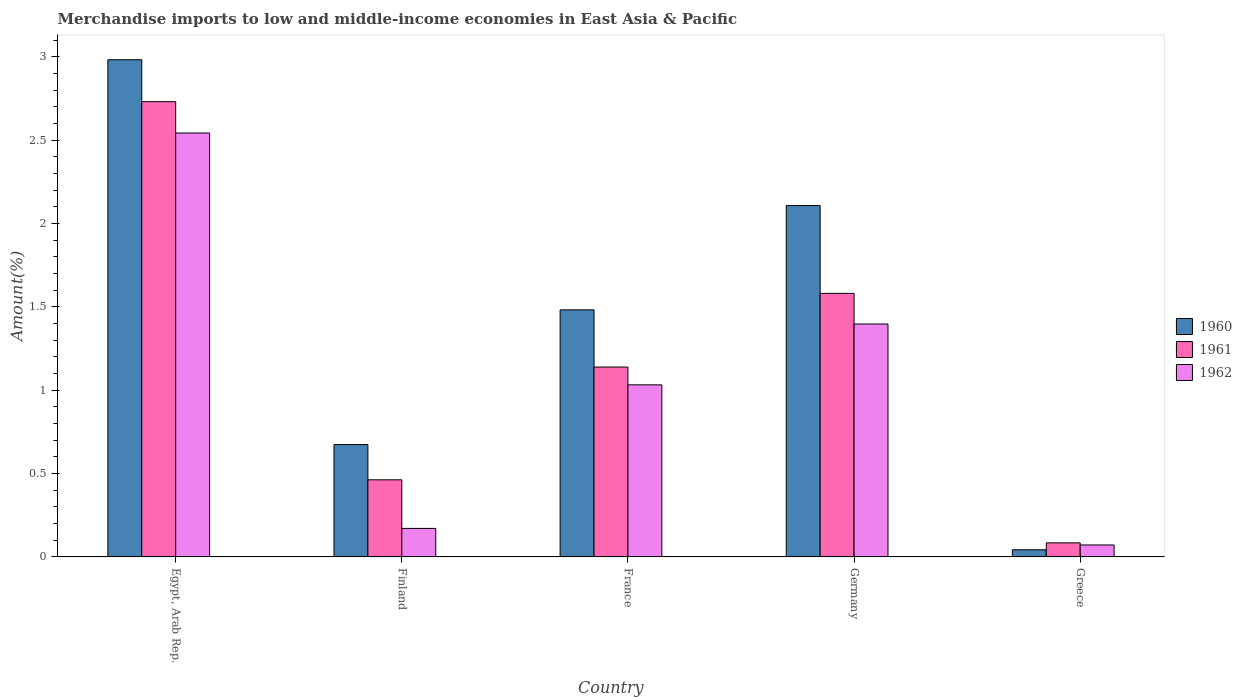How many groups of bars are there?
Provide a succinct answer. 5. Are the number of bars per tick equal to the number of legend labels?
Your answer should be very brief. Yes. Are the number of bars on each tick of the X-axis equal?
Offer a terse response. Yes. What is the label of the 1st group of bars from the left?
Make the answer very short. Egypt, Arab Rep. In how many cases, is the number of bars for a given country not equal to the number of legend labels?
Offer a terse response. 0. What is the percentage of amount earned from merchandise imports in 1960 in Germany?
Provide a succinct answer. 2.11. Across all countries, what is the maximum percentage of amount earned from merchandise imports in 1961?
Offer a terse response. 2.73. Across all countries, what is the minimum percentage of amount earned from merchandise imports in 1962?
Provide a succinct answer. 0.07. In which country was the percentage of amount earned from merchandise imports in 1962 maximum?
Keep it short and to the point. Egypt, Arab Rep. In which country was the percentage of amount earned from merchandise imports in 1962 minimum?
Ensure brevity in your answer.  Greece. What is the total percentage of amount earned from merchandise imports in 1961 in the graph?
Make the answer very short. 6. What is the difference between the percentage of amount earned from merchandise imports in 1960 in Finland and that in Germany?
Your response must be concise. -1.43. What is the difference between the percentage of amount earned from merchandise imports in 1960 in Greece and the percentage of amount earned from merchandise imports in 1961 in Egypt, Arab Rep.?
Offer a very short reply. -2.69. What is the average percentage of amount earned from merchandise imports in 1961 per country?
Your response must be concise. 1.2. What is the difference between the percentage of amount earned from merchandise imports of/in 1961 and percentage of amount earned from merchandise imports of/in 1962 in Greece?
Your response must be concise. 0.01. What is the ratio of the percentage of amount earned from merchandise imports in 1960 in Egypt, Arab Rep. to that in Germany?
Provide a short and direct response. 1.42. Is the difference between the percentage of amount earned from merchandise imports in 1961 in Egypt, Arab Rep. and Germany greater than the difference between the percentage of amount earned from merchandise imports in 1962 in Egypt, Arab Rep. and Germany?
Make the answer very short. Yes. What is the difference between the highest and the second highest percentage of amount earned from merchandise imports in 1962?
Make the answer very short. -1.15. What is the difference between the highest and the lowest percentage of amount earned from merchandise imports in 1960?
Offer a terse response. 2.94. In how many countries, is the percentage of amount earned from merchandise imports in 1962 greater than the average percentage of amount earned from merchandise imports in 1962 taken over all countries?
Provide a succinct answer. 2. Is it the case that in every country, the sum of the percentage of amount earned from merchandise imports in 1961 and percentage of amount earned from merchandise imports in 1960 is greater than the percentage of amount earned from merchandise imports in 1962?
Your answer should be compact. Yes. How many bars are there?
Ensure brevity in your answer.  15. Are all the bars in the graph horizontal?
Ensure brevity in your answer.  No. Does the graph contain any zero values?
Keep it short and to the point. No. Does the graph contain grids?
Ensure brevity in your answer.  No. Where does the legend appear in the graph?
Your answer should be very brief. Center right. How are the legend labels stacked?
Keep it short and to the point. Vertical. What is the title of the graph?
Your response must be concise. Merchandise imports to low and middle-income economies in East Asia & Pacific. What is the label or title of the X-axis?
Give a very brief answer. Country. What is the label or title of the Y-axis?
Your response must be concise. Amount(%). What is the Amount(%) of 1960 in Egypt, Arab Rep.?
Provide a succinct answer. 2.98. What is the Amount(%) in 1961 in Egypt, Arab Rep.?
Ensure brevity in your answer.  2.73. What is the Amount(%) in 1962 in Egypt, Arab Rep.?
Your response must be concise. 2.54. What is the Amount(%) in 1960 in Finland?
Give a very brief answer. 0.67. What is the Amount(%) in 1961 in Finland?
Make the answer very short. 0.46. What is the Amount(%) in 1962 in Finland?
Your answer should be very brief. 0.17. What is the Amount(%) of 1960 in France?
Your answer should be very brief. 1.48. What is the Amount(%) of 1961 in France?
Make the answer very short. 1.14. What is the Amount(%) of 1962 in France?
Provide a short and direct response. 1.03. What is the Amount(%) of 1960 in Germany?
Keep it short and to the point. 2.11. What is the Amount(%) of 1961 in Germany?
Your answer should be compact. 1.58. What is the Amount(%) of 1962 in Germany?
Your answer should be compact. 1.4. What is the Amount(%) in 1960 in Greece?
Keep it short and to the point. 0.04. What is the Amount(%) in 1961 in Greece?
Make the answer very short. 0.08. What is the Amount(%) in 1962 in Greece?
Offer a terse response. 0.07. Across all countries, what is the maximum Amount(%) of 1960?
Provide a short and direct response. 2.98. Across all countries, what is the maximum Amount(%) in 1961?
Your response must be concise. 2.73. Across all countries, what is the maximum Amount(%) in 1962?
Your answer should be very brief. 2.54. Across all countries, what is the minimum Amount(%) of 1960?
Your response must be concise. 0.04. Across all countries, what is the minimum Amount(%) in 1961?
Your answer should be compact. 0.08. Across all countries, what is the minimum Amount(%) in 1962?
Give a very brief answer. 0.07. What is the total Amount(%) in 1960 in the graph?
Offer a very short reply. 7.29. What is the total Amount(%) of 1961 in the graph?
Your answer should be very brief. 6. What is the total Amount(%) of 1962 in the graph?
Make the answer very short. 5.21. What is the difference between the Amount(%) of 1960 in Egypt, Arab Rep. and that in Finland?
Offer a very short reply. 2.31. What is the difference between the Amount(%) in 1961 in Egypt, Arab Rep. and that in Finland?
Your response must be concise. 2.27. What is the difference between the Amount(%) of 1962 in Egypt, Arab Rep. and that in Finland?
Your answer should be very brief. 2.37. What is the difference between the Amount(%) of 1961 in Egypt, Arab Rep. and that in France?
Your answer should be very brief. 1.59. What is the difference between the Amount(%) in 1962 in Egypt, Arab Rep. and that in France?
Offer a terse response. 1.51. What is the difference between the Amount(%) of 1960 in Egypt, Arab Rep. and that in Germany?
Provide a short and direct response. 0.87. What is the difference between the Amount(%) in 1961 in Egypt, Arab Rep. and that in Germany?
Your response must be concise. 1.15. What is the difference between the Amount(%) of 1962 in Egypt, Arab Rep. and that in Germany?
Ensure brevity in your answer.  1.15. What is the difference between the Amount(%) in 1960 in Egypt, Arab Rep. and that in Greece?
Ensure brevity in your answer.  2.94. What is the difference between the Amount(%) in 1961 in Egypt, Arab Rep. and that in Greece?
Make the answer very short. 2.65. What is the difference between the Amount(%) in 1962 in Egypt, Arab Rep. and that in Greece?
Ensure brevity in your answer.  2.47. What is the difference between the Amount(%) of 1960 in Finland and that in France?
Your response must be concise. -0.81. What is the difference between the Amount(%) in 1961 in Finland and that in France?
Keep it short and to the point. -0.68. What is the difference between the Amount(%) of 1962 in Finland and that in France?
Your answer should be very brief. -0.86. What is the difference between the Amount(%) of 1960 in Finland and that in Germany?
Your answer should be compact. -1.43. What is the difference between the Amount(%) of 1961 in Finland and that in Germany?
Your answer should be compact. -1.12. What is the difference between the Amount(%) of 1962 in Finland and that in Germany?
Your answer should be compact. -1.23. What is the difference between the Amount(%) of 1960 in Finland and that in Greece?
Offer a terse response. 0.63. What is the difference between the Amount(%) in 1961 in Finland and that in Greece?
Provide a succinct answer. 0.38. What is the difference between the Amount(%) in 1962 in Finland and that in Greece?
Provide a short and direct response. 0.1. What is the difference between the Amount(%) of 1960 in France and that in Germany?
Provide a succinct answer. -0.63. What is the difference between the Amount(%) in 1961 in France and that in Germany?
Offer a terse response. -0.44. What is the difference between the Amount(%) in 1962 in France and that in Germany?
Offer a very short reply. -0.36. What is the difference between the Amount(%) of 1960 in France and that in Greece?
Your response must be concise. 1.44. What is the difference between the Amount(%) in 1961 in France and that in Greece?
Your answer should be very brief. 1.05. What is the difference between the Amount(%) of 1962 in France and that in Greece?
Keep it short and to the point. 0.96. What is the difference between the Amount(%) of 1960 in Germany and that in Greece?
Offer a terse response. 2.06. What is the difference between the Amount(%) of 1961 in Germany and that in Greece?
Your response must be concise. 1.5. What is the difference between the Amount(%) in 1962 in Germany and that in Greece?
Provide a short and direct response. 1.33. What is the difference between the Amount(%) in 1960 in Egypt, Arab Rep. and the Amount(%) in 1961 in Finland?
Your answer should be compact. 2.52. What is the difference between the Amount(%) in 1960 in Egypt, Arab Rep. and the Amount(%) in 1962 in Finland?
Your answer should be very brief. 2.81. What is the difference between the Amount(%) in 1961 in Egypt, Arab Rep. and the Amount(%) in 1962 in Finland?
Ensure brevity in your answer.  2.56. What is the difference between the Amount(%) in 1960 in Egypt, Arab Rep. and the Amount(%) in 1961 in France?
Your answer should be very brief. 1.84. What is the difference between the Amount(%) in 1960 in Egypt, Arab Rep. and the Amount(%) in 1962 in France?
Offer a very short reply. 1.95. What is the difference between the Amount(%) in 1961 in Egypt, Arab Rep. and the Amount(%) in 1962 in France?
Offer a terse response. 1.7. What is the difference between the Amount(%) of 1960 in Egypt, Arab Rep. and the Amount(%) of 1961 in Germany?
Provide a succinct answer. 1.4. What is the difference between the Amount(%) of 1960 in Egypt, Arab Rep. and the Amount(%) of 1962 in Germany?
Your response must be concise. 1.58. What is the difference between the Amount(%) of 1961 in Egypt, Arab Rep. and the Amount(%) of 1962 in Germany?
Offer a terse response. 1.33. What is the difference between the Amount(%) of 1960 in Egypt, Arab Rep. and the Amount(%) of 1961 in Greece?
Offer a terse response. 2.9. What is the difference between the Amount(%) of 1960 in Egypt, Arab Rep. and the Amount(%) of 1962 in Greece?
Provide a short and direct response. 2.91. What is the difference between the Amount(%) of 1961 in Egypt, Arab Rep. and the Amount(%) of 1962 in Greece?
Offer a very short reply. 2.66. What is the difference between the Amount(%) of 1960 in Finland and the Amount(%) of 1961 in France?
Ensure brevity in your answer.  -0.47. What is the difference between the Amount(%) in 1960 in Finland and the Amount(%) in 1962 in France?
Provide a short and direct response. -0.36. What is the difference between the Amount(%) of 1961 in Finland and the Amount(%) of 1962 in France?
Make the answer very short. -0.57. What is the difference between the Amount(%) in 1960 in Finland and the Amount(%) in 1961 in Germany?
Give a very brief answer. -0.91. What is the difference between the Amount(%) of 1960 in Finland and the Amount(%) of 1962 in Germany?
Your answer should be compact. -0.72. What is the difference between the Amount(%) in 1961 in Finland and the Amount(%) in 1962 in Germany?
Give a very brief answer. -0.93. What is the difference between the Amount(%) in 1960 in Finland and the Amount(%) in 1961 in Greece?
Ensure brevity in your answer.  0.59. What is the difference between the Amount(%) of 1960 in Finland and the Amount(%) of 1962 in Greece?
Provide a short and direct response. 0.6. What is the difference between the Amount(%) of 1961 in Finland and the Amount(%) of 1962 in Greece?
Ensure brevity in your answer.  0.39. What is the difference between the Amount(%) of 1960 in France and the Amount(%) of 1961 in Germany?
Keep it short and to the point. -0.1. What is the difference between the Amount(%) in 1960 in France and the Amount(%) in 1962 in Germany?
Your answer should be very brief. 0.08. What is the difference between the Amount(%) in 1961 in France and the Amount(%) in 1962 in Germany?
Offer a terse response. -0.26. What is the difference between the Amount(%) in 1960 in France and the Amount(%) in 1961 in Greece?
Ensure brevity in your answer.  1.4. What is the difference between the Amount(%) in 1960 in France and the Amount(%) in 1962 in Greece?
Offer a very short reply. 1.41. What is the difference between the Amount(%) of 1961 in France and the Amount(%) of 1962 in Greece?
Your response must be concise. 1.07. What is the difference between the Amount(%) in 1960 in Germany and the Amount(%) in 1961 in Greece?
Make the answer very short. 2.02. What is the difference between the Amount(%) of 1960 in Germany and the Amount(%) of 1962 in Greece?
Provide a short and direct response. 2.04. What is the difference between the Amount(%) in 1961 in Germany and the Amount(%) in 1962 in Greece?
Your answer should be very brief. 1.51. What is the average Amount(%) of 1960 per country?
Offer a terse response. 1.46. What is the average Amount(%) in 1961 per country?
Provide a short and direct response. 1.2. What is the average Amount(%) of 1962 per country?
Your answer should be very brief. 1.04. What is the difference between the Amount(%) of 1960 and Amount(%) of 1961 in Egypt, Arab Rep.?
Provide a succinct answer. 0.25. What is the difference between the Amount(%) in 1960 and Amount(%) in 1962 in Egypt, Arab Rep.?
Offer a very short reply. 0.44. What is the difference between the Amount(%) in 1961 and Amount(%) in 1962 in Egypt, Arab Rep.?
Ensure brevity in your answer.  0.19. What is the difference between the Amount(%) in 1960 and Amount(%) in 1961 in Finland?
Keep it short and to the point. 0.21. What is the difference between the Amount(%) of 1960 and Amount(%) of 1962 in Finland?
Provide a succinct answer. 0.5. What is the difference between the Amount(%) of 1961 and Amount(%) of 1962 in Finland?
Offer a very short reply. 0.29. What is the difference between the Amount(%) in 1960 and Amount(%) in 1961 in France?
Your response must be concise. 0.34. What is the difference between the Amount(%) of 1960 and Amount(%) of 1962 in France?
Offer a terse response. 0.45. What is the difference between the Amount(%) in 1961 and Amount(%) in 1962 in France?
Provide a succinct answer. 0.11. What is the difference between the Amount(%) of 1960 and Amount(%) of 1961 in Germany?
Keep it short and to the point. 0.53. What is the difference between the Amount(%) of 1960 and Amount(%) of 1962 in Germany?
Give a very brief answer. 0.71. What is the difference between the Amount(%) in 1961 and Amount(%) in 1962 in Germany?
Your response must be concise. 0.18. What is the difference between the Amount(%) in 1960 and Amount(%) in 1961 in Greece?
Make the answer very short. -0.04. What is the difference between the Amount(%) of 1960 and Amount(%) of 1962 in Greece?
Provide a short and direct response. -0.03. What is the difference between the Amount(%) in 1961 and Amount(%) in 1962 in Greece?
Provide a short and direct response. 0.01. What is the ratio of the Amount(%) of 1960 in Egypt, Arab Rep. to that in Finland?
Offer a terse response. 4.43. What is the ratio of the Amount(%) in 1961 in Egypt, Arab Rep. to that in Finland?
Make the answer very short. 5.9. What is the ratio of the Amount(%) in 1962 in Egypt, Arab Rep. to that in Finland?
Your answer should be compact. 14.87. What is the ratio of the Amount(%) of 1960 in Egypt, Arab Rep. to that in France?
Ensure brevity in your answer.  2.01. What is the ratio of the Amount(%) in 1961 in Egypt, Arab Rep. to that in France?
Offer a terse response. 2.4. What is the ratio of the Amount(%) in 1962 in Egypt, Arab Rep. to that in France?
Give a very brief answer. 2.46. What is the ratio of the Amount(%) of 1960 in Egypt, Arab Rep. to that in Germany?
Ensure brevity in your answer.  1.42. What is the ratio of the Amount(%) in 1961 in Egypt, Arab Rep. to that in Germany?
Make the answer very short. 1.73. What is the ratio of the Amount(%) of 1962 in Egypt, Arab Rep. to that in Germany?
Make the answer very short. 1.82. What is the ratio of the Amount(%) of 1960 in Egypt, Arab Rep. to that in Greece?
Provide a short and direct response. 69.41. What is the ratio of the Amount(%) of 1961 in Egypt, Arab Rep. to that in Greece?
Make the answer very short. 32.33. What is the ratio of the Amount(%) in 1962 in Egypt, Arab Rep. to that in Greece?
Your answer should be very brief. 35.41. What is the ratio of the Amount(%) of 1960 in Finland to that in France?
Offer a very short reply. 0.45. What is the ratio of the Amount(%) of 1961 in Finland to that in France?
Offer a terse response. 0.41. What is the ratio of the Amount(%) of 1962 in Finland to that in France?
Your response must be concise. 0.17. What is the ratio of the Amount(%) of 1960 in Finland to that in Germany?
Offer a very short reply. 0.32. What is the ratio of the Amount(%) of 1961 in Finland to that in Germany?
Your response must be concise. 0.29. What is the ratio of the Amount(%) of 1962 in Finland to that in Germany?
Ensure brevity in your answer.  0.12. What is the ratio of the Amount(%) of 1960 in Finland to that in Greece?
Your response must be concise. 15.68. What is the ratio of the Amount(%) in 1961 in Finland to that in Greece?
Your answer should be compact. 5.48. What is the ratio of the Amount(%) of 1962 in Finland to that in Greece?
Make the answer very short. 2.38. What is the ratio of the Amount(%) of 1960 in France to that in Germany?
Provide a succinct answer. 0.7. What is the ratio of the Amount(%) of 1961 in France to that in Germany?
Give a very brief answer. 0.72. What is the ratio of the Amount(%) of 1962 in France to that in Germany?
Ensure brevity in your answer.  0.74. What is the ratio of the Amount(%) in 1960 in France to that in Greece?
Provide a succinct answer. 34.49. What is the ratio of the Amount(%) in 1961 in France to that in Greece?
Offer a terse response. 13.48. What is the ratio of the Amount(%) of 1962 in France to that in Greece?
Give a very brief answer. 14.37. What is the ratio of the Amount(%) in 1960 in Germany to that in Greece?
Provide a short and direct response. 49.05. What is the ratio of the Amount(%) in 1961 in Germany to that in Greece?
Your response must be concise. 18.72. What is the ratio of the Amount(%) of 1962 in Germany to that in Greece?
Keep it short and to the point. 19.46. What is the difference between the highest and the second highest Amount(%) in 1960?
Give a very brief answer. 0.87. What is the difference between the highest and the second highest Amount(%) of 1961?
Offer a very short reply. 1.15. What is the difference between the highest and the second highest Amount(%) of 1962?
Keep it short and to the point. 1.15. What is the difference between the highest and the lowest Amount(%) of 1960?
Provide a succinct answer. 2.94. What is the difference between the highest and the lowest Amount(%) in 1961?
Your answer should be compact. 2.65. What is the difference between the highest and the lowest Amount(%) in 1962?
Your response must be concise. 2.47. 